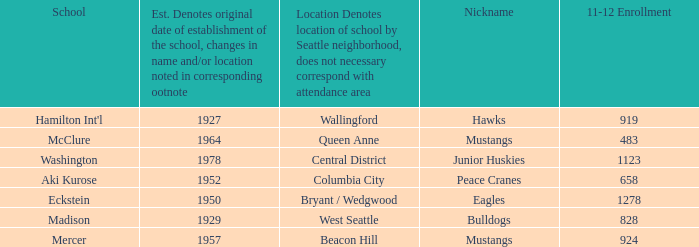Name the most 11-12 enrollment for columbia city 658.0. 